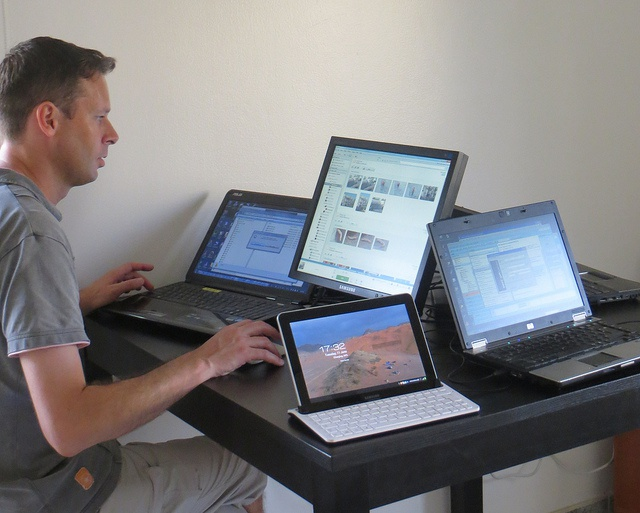Describe the objects in this image and their specific colors. I can see people in darkgray, gray, brown, and black tones, dining table in darkgray, black, and gray tones, laptop in darkgray, lightblue, black, and gray tones, laptop in darkgray, black, and gray tones, and tv in darkgray and lightblue tones in this image. 